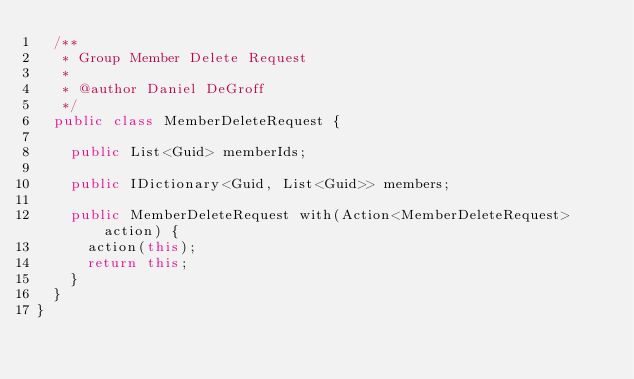<code> <loc_0><loc_0><loc_500><loc_500><_C#_>  /**
   * Group Member Delete Request
   *
   * @author Daniel DeGroff
   */
  public class MemberDeleteRequest {

    public List<Guid> memberIds;

    public IDictionary<Guid, List<Guid>> members;

    public MemberDeleteRequest with(Action<MemberDeleteRequest> action) {
      action(this);
      return this;
    }
  }
}
</code> 